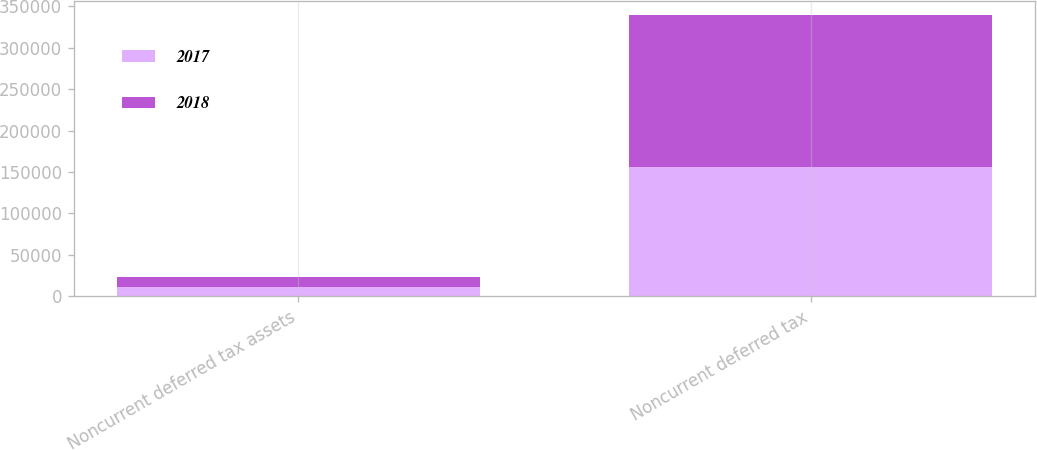<chart> <loc_0><loc_0><loc_500><loc_500><stacked_bar_chart><ecel><fcel>Noncurrent deferred tax assets<fcel>Noncurrent deferred tax<nl><fcel>2017<fcel>11422<fcel>155728<nl><fcel>2018<fcel>11677<fcel>183836<nl></chart> 